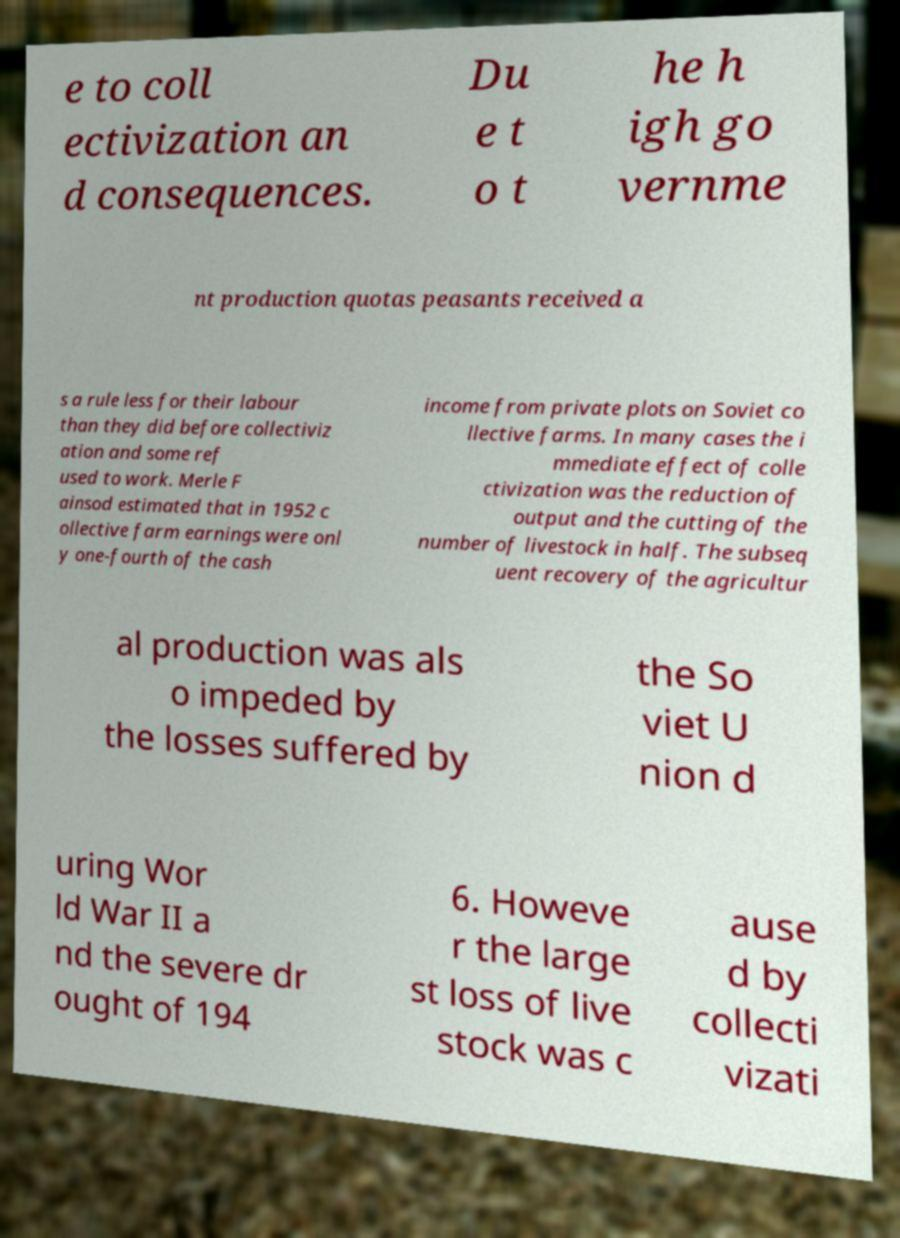There's text embedded in this image that I need extracted. Can you transcribe it verbatim? e to coll ectivization an d consequences. Du e t o t he h igh go vernme nt production quotas peasants received a s a rule less for their labour than they did before collectiviz ation and some ref used to work. Merle F ainsod estimated that in 1952 c ollective farm earnings were onl y one-fourth of the cash income from private plots on Soviet co llective farms. In many cases the i mmediate effect of colle ctivization was the reduction of output and the cutting of the number of livestock in half. The subseq uent recovery of the agricultur al production was als o impeded by the losses suffered by the So viet U nion d uring Wor ld War II a nd the severe dr ought of 194 6. Howeve r the large st loss of live stock was c ause d by collecti vizati 